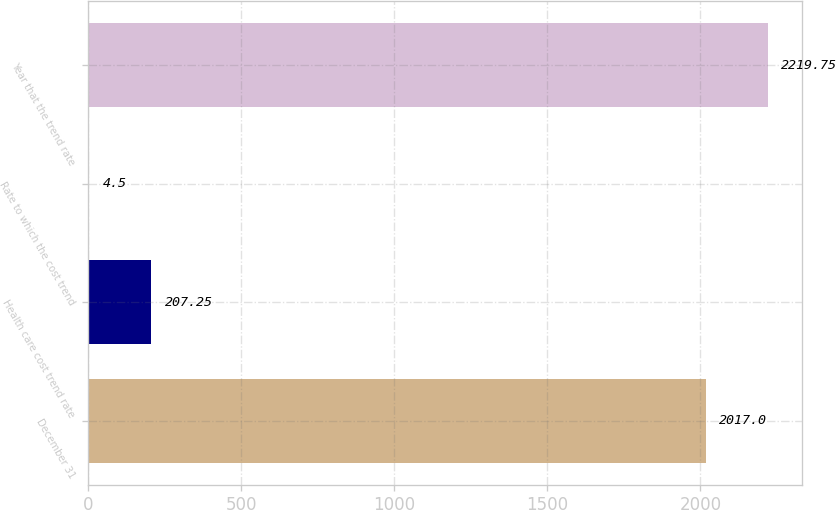<chart> <loc_0><loc_0><loc_500><loc_500><bar_chart><fcel>December 31<fcel>Health care cost trend rate<fcel>Rate to which the cost trend<fcel>Year that the trend rate<nl><fcel>2017<fcel>207.25<fcel>4.5<fcel>2219.75<nl></chart> 